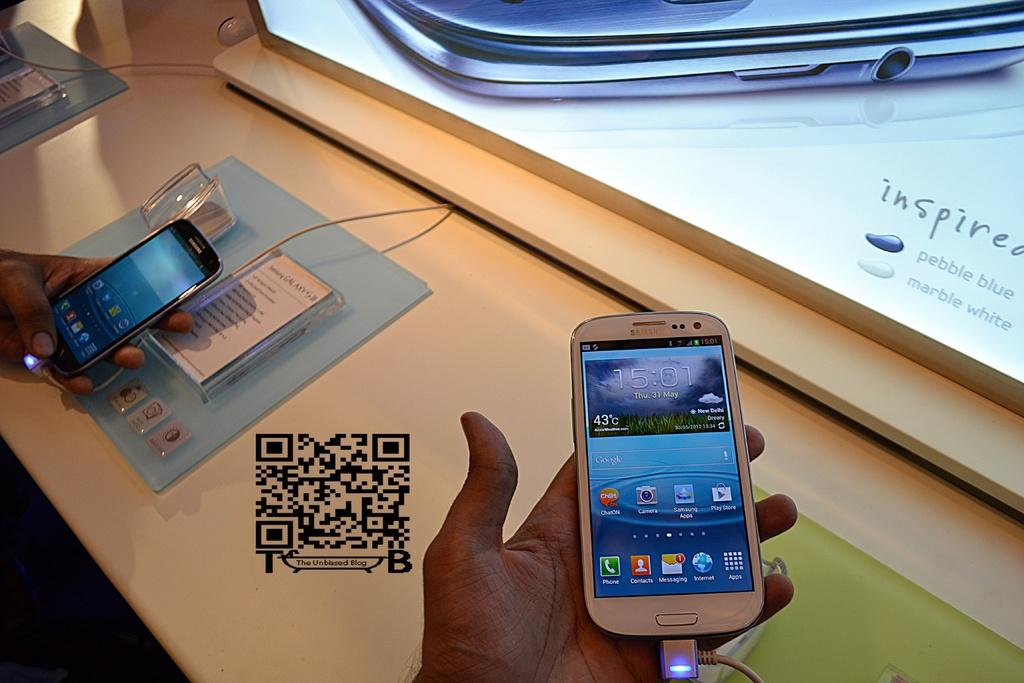Provide a one-sentence caption for the provided image. A man holds a Samsung phone at a kiosk with a QR code on the table. 